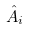Convert formula to latex. <formula><loc_0><loc_0><loc_500><loc_500>\hat { A } _ { i }</formula> 